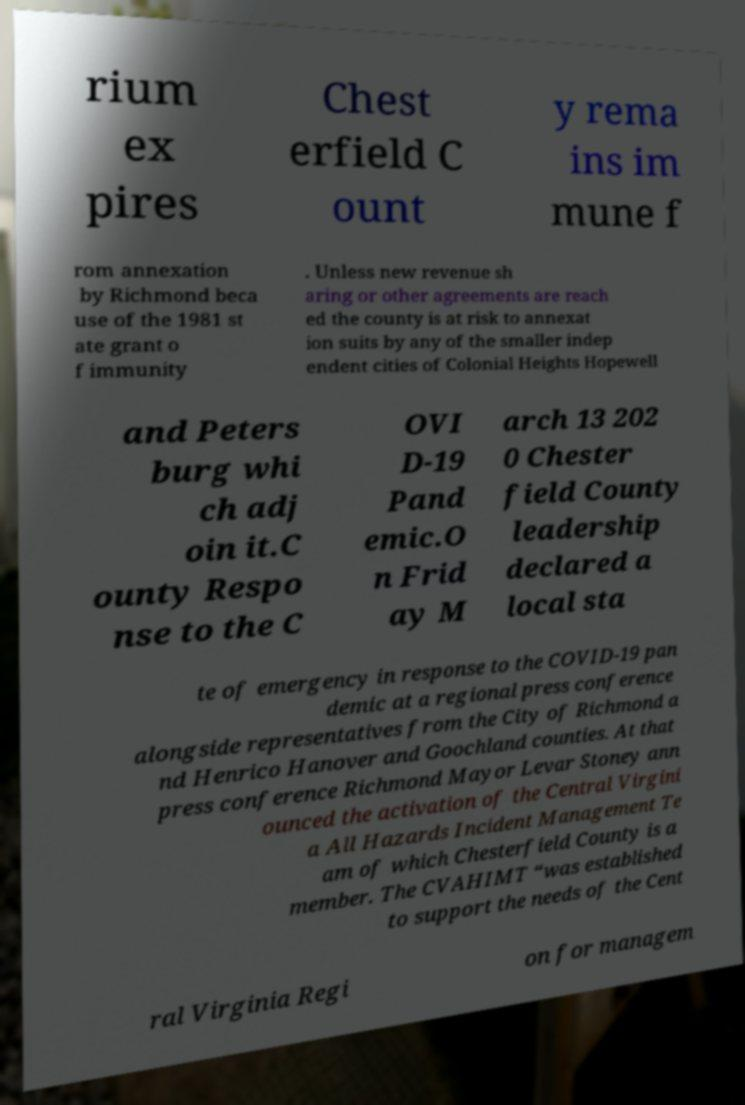There's text embedded in this image that I need extracted. Can you transcribe it verbatim? rium ex pires Chest erfield C ount y rema ins im mune f rom annexation by Richmond beca use of the 1981 st ate grant o f immunity . Unless new revenue sh aring or other agreements are reach ed the county is at risk to annexat ion suits by any of the smaller indep endent cities of Colonial Heights Hopewell and Peters burg whi ch adj oin it.C ounty Respo nse to the C OVI D-19 Pand emic.O n Frid ay M arch 13 202 0 Chester field County leadership declared a local sta te of emergency in response to the COVID-19 pan demic at a regional press conference alongside representatives from the City of Richmond a nd Henrico Hanover and Goochland counties. At that press conference Richmond Mayor Levar Stoney ann ounced the activation of the Central Virgini a All Hazards Incident Management Te am of which Chesterfield County is a member. The CVAHIMT “was established to support the needs of the Cent ral Virginia Regi on for managem 